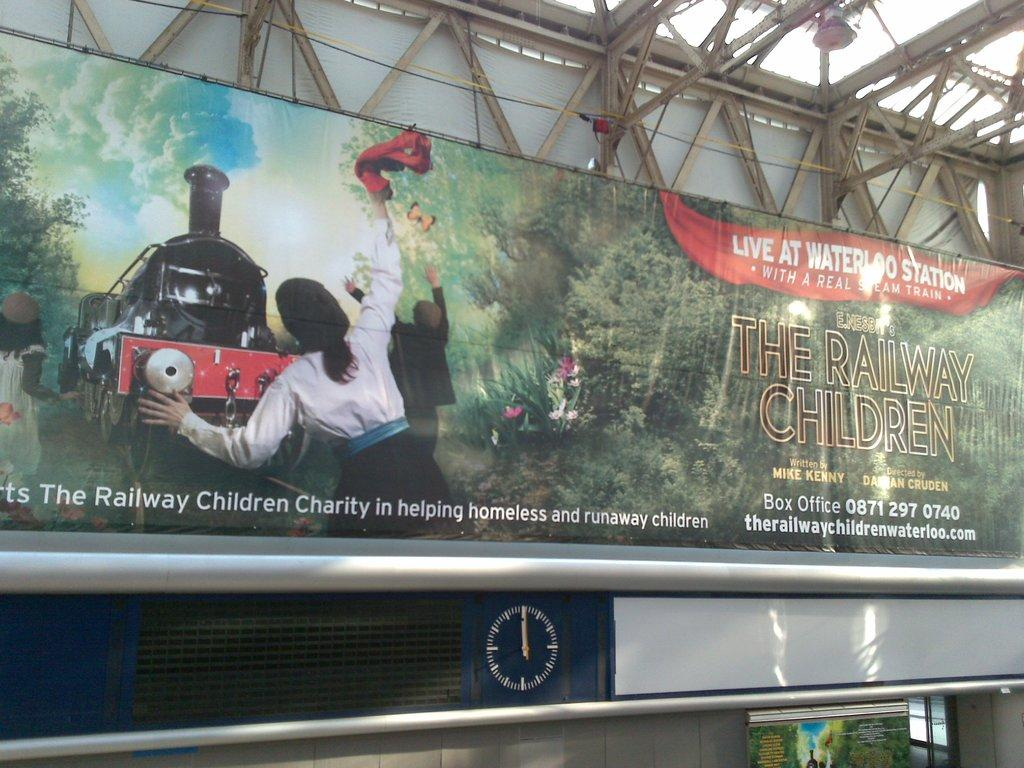Provide a one-sentence caption for the provided image. An advertisement for The Railway Children playing at waterloo station. 